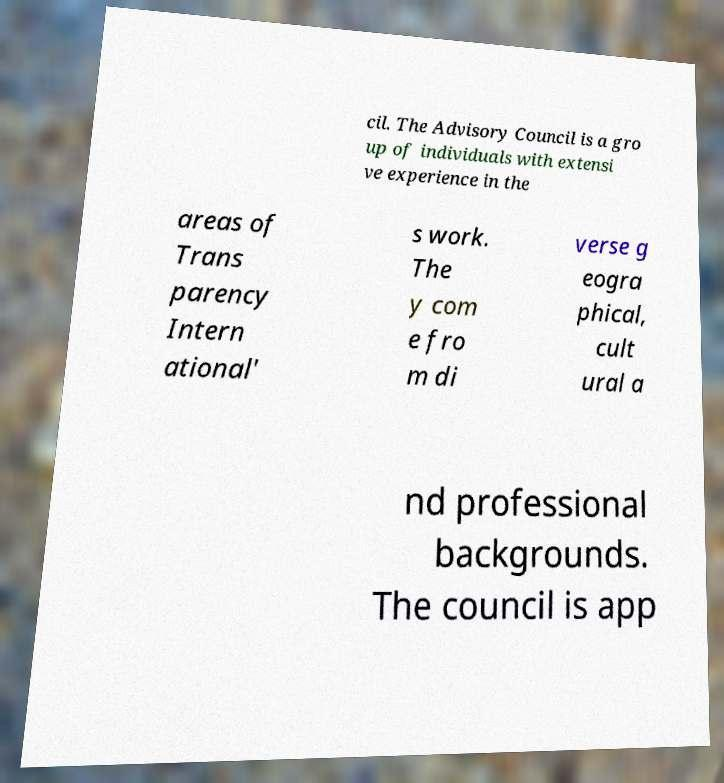Please identify and transcribe the text found in this image. cil. The Advisory Council is a gro up of individuals with extensi ve experience in the areas of Trans parency Intern ational' s work. The y com e fro m di verse g eogra phical, cult ural a nd professional backgrounds. The council is app 